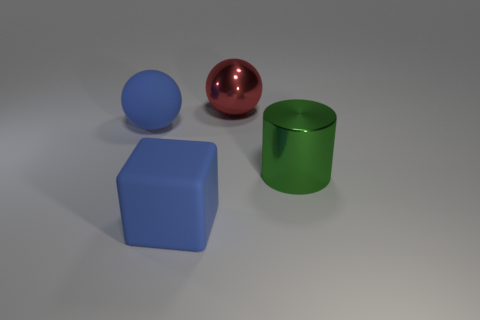Add 3 big matte things. How many objects exist? 7 Subtract all cylinders. How many objects are left? 3 Add 1 blue blocks. How many blue blocks exist? 2 Subtract 0 red cubes. How many objects are left? 4 Subtract all large metal blocks. Subtract all big metallic objects. How many objects are left? 2 Add 2 green metallic cylinders. How many green metallic cylinders are left? 3 